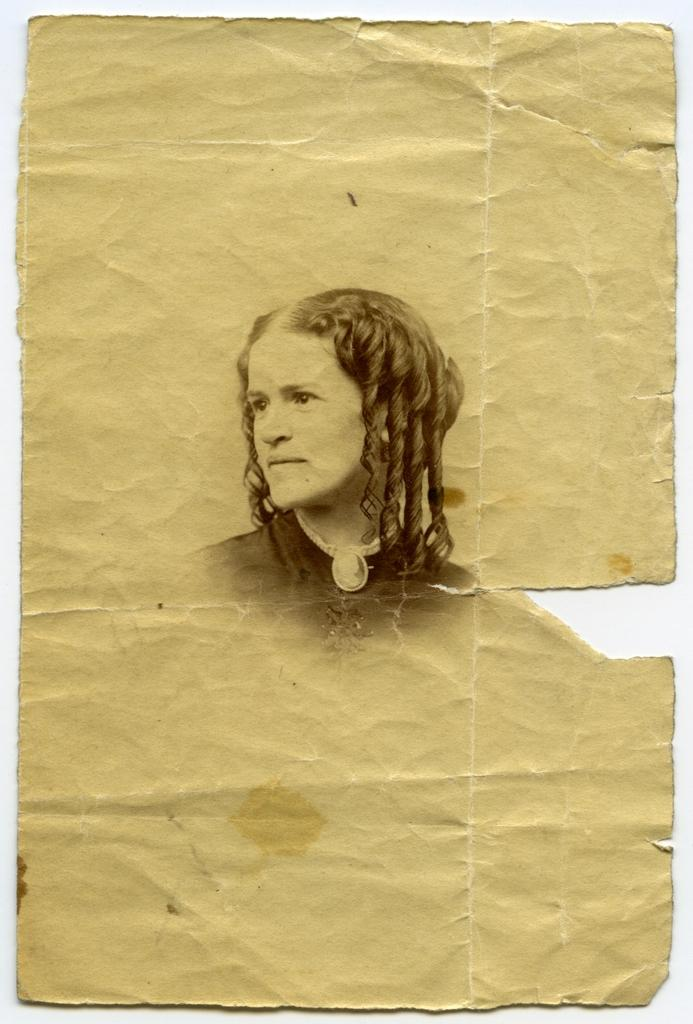What is depicted on the paper in the image? There is a printed image of a woman on the paper. How many chairs are visible in the image? There are no chairs visible in the image; it only features a printed image of a woman on the paper. What time of day is depicted in the image? The time of day cannot be determined from the image, as it only features a printed image of a woman on the paper. 